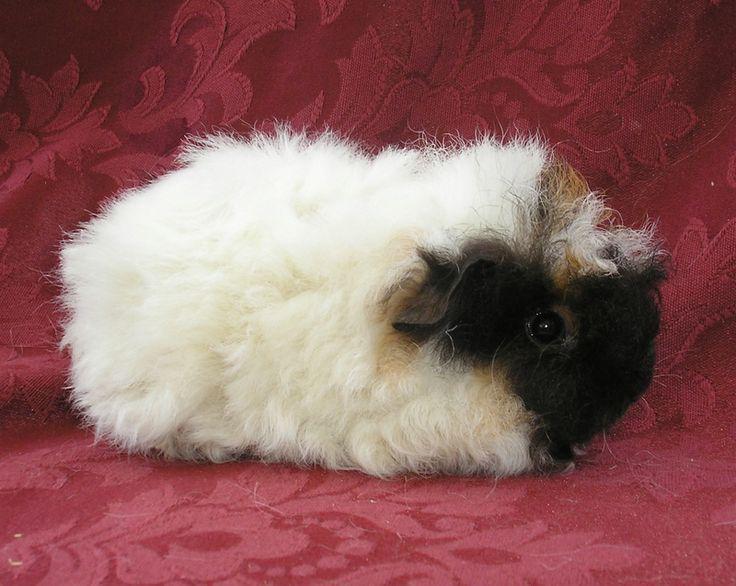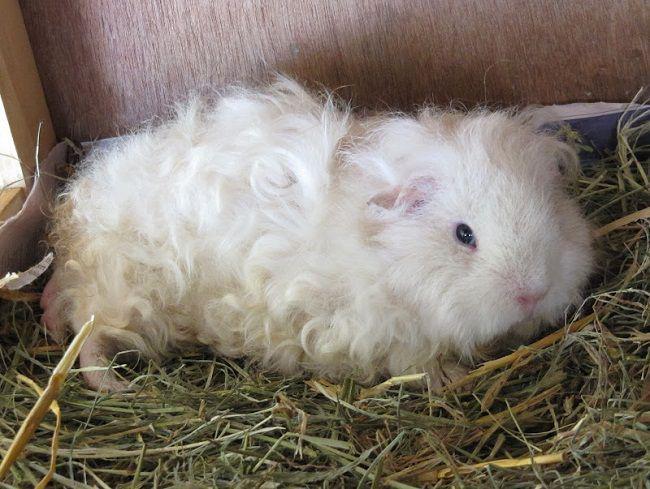The first image is the image on the left, the second image is the image on the right. Assess this claim about the two images: "There is no brown fur on these guinea pigs.". Correct or not? Answer yes or no. Yes. 